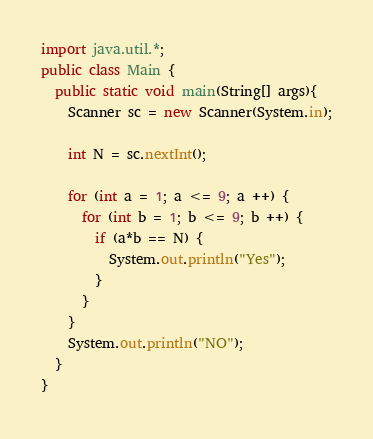<code> <loc_0><loc_0><loc_500><loc_500><_Java_>import java.util.*;
public class Main {
  public static void main(String[] args){
    Scanner sc = new Scanner(System.in);
    
    int N = sc.nextInt();
    
    for (int a = 1; a <= 9; a ++) {
      for (int b = 1; b <= 9; b ++) {
        if (a*b == N) {
          System.out.println("Yes");
        }
      }
    }
    System.out.println("NO");
  }
}</code> 